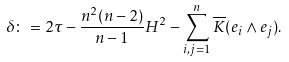<formula> <loc_0><loc_0><loc_500><loc_500>\delta \colon = 2 \tau - \frac { n ^ { 2 } ( n - 2 ) } { n - 1 } H ^ { 2 } - \sum _ { i , j = 1 } ^ { n } \overline { K } ( e _ { i } \wedge e _ { j } ) .</formula> 